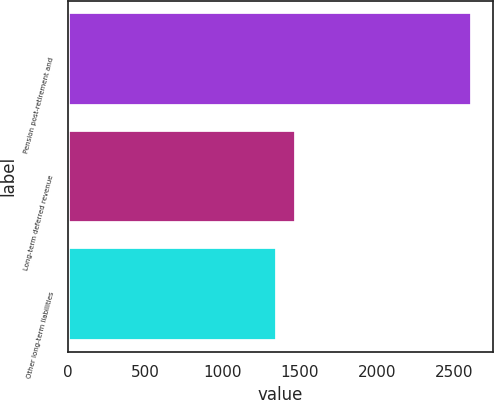Convert chart. <chart><loc_0><loc_0><loc_500><loc_500><bar_chart><fcel>Pension post-retirement and<fcel>Long-term deferred revenue<fcel>Other long-term liabilities<nl><fcel>2620<fcel>1479.7<fcel>1353<nl></chart> 